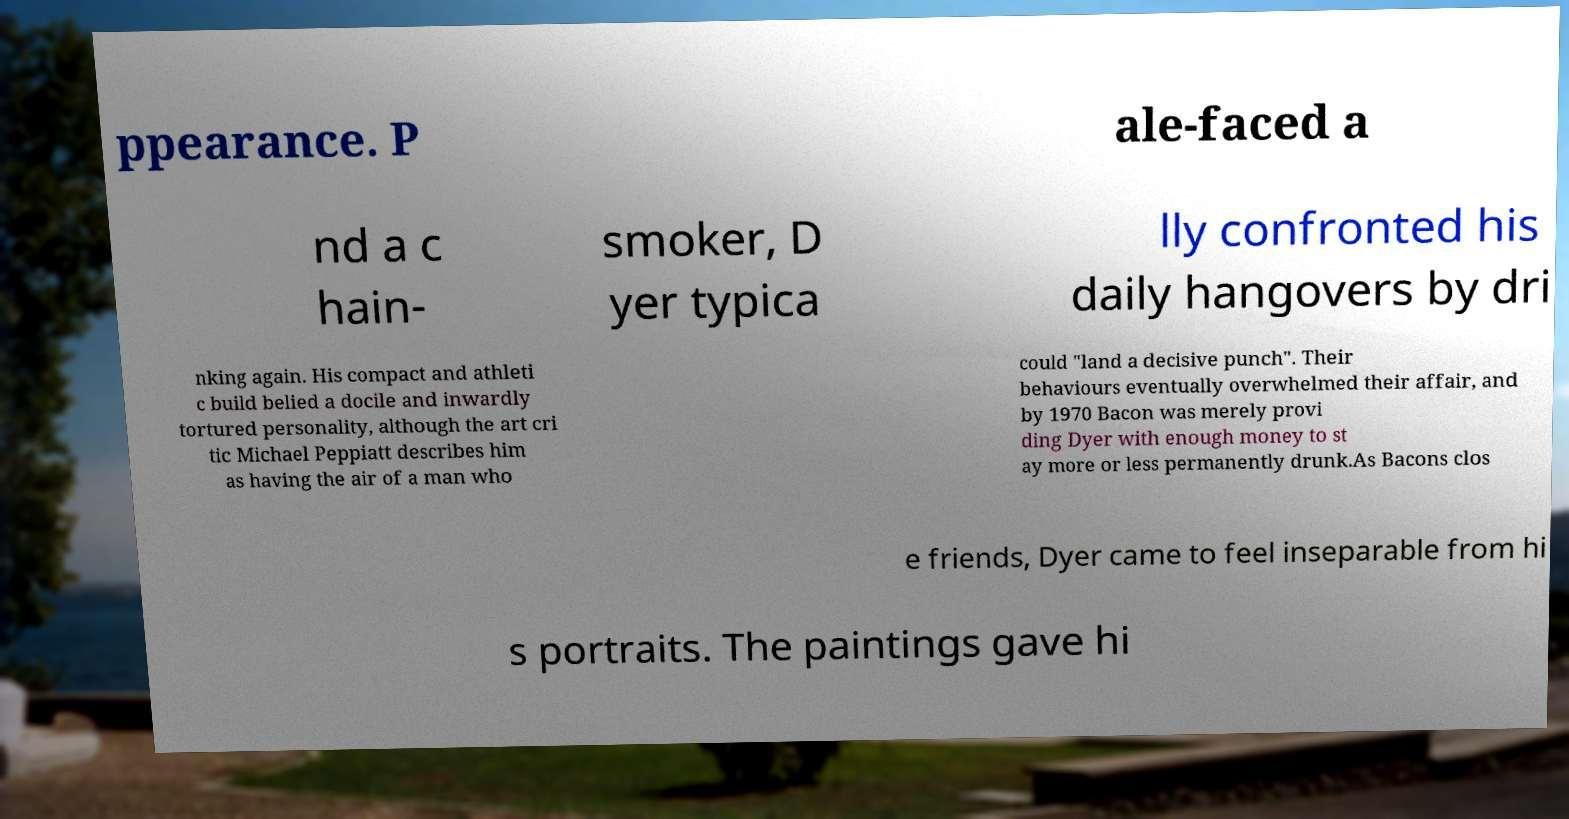Could you extract and type out the text from this image? ppearance. P ale-faced a nd a c hain- smoker, D yer typica lly confronted his daily hangovers by dri nking again. His compact and athleti c build belied a docile and inwardly tortured personality, although the art cri tic Michael Peppiatt describes him as having the air of a man who could "land a decisive punch". Their behaviours eventually overwhelmed their affair, and by 1970 Bacon was merely provi ding Dyer with enough money to st ay more or less permanently drunk.As Bacons clos e friends, Dyer came to feel inseparable from hi s portraits. The paintings gave hi 